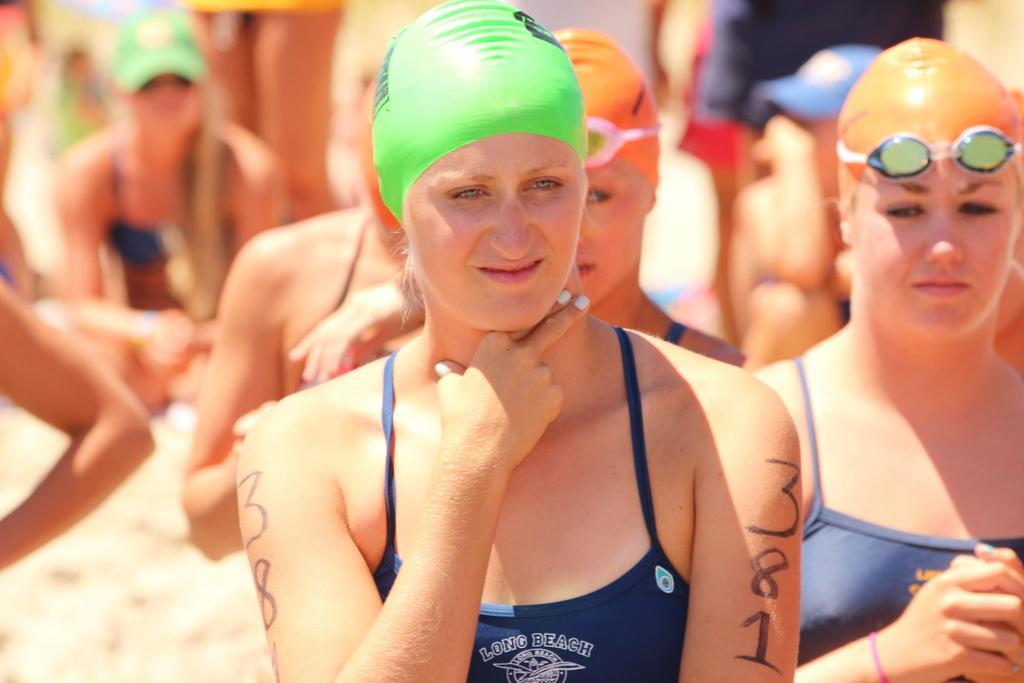What is the main subject of the image? The main subject of the image is a group of women. How are the women positioned in the image? Some women are standing, while others are sitting on the ground. What can be observed about the women sitting on the ground? The women sitting on the ground are wearing caps. What type of turkey is being served at the historical event depicted in the image? There is no turkey or historical event present in the image; it features a group of women, some standing and others sitting on the ground wearing caps. How many feet are visible in the image? The image does not show any feet; it focuses on the women's positions and the caps they are wearing. 